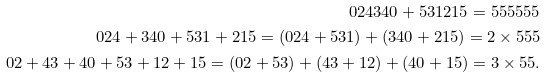<formula> <loc_0><loc_0><loc_500><loc_500>0 2 4 3 4 0 + 5 3 1 2 1 5 = 5 5 5 5 5 5 \\ 0 2 4 + 3 4 0 + 5 3 1 + 2 1 5 = ( 0 2 4 + 5 3 1 ) + ( 3 4 0 + 2 1 5 ) = 2 \times 5 5 5 \\ 0 2 + 4 3 + 4 0 + 5 3 + 1 2 + 1 5 = ( 0 2 + 5 3 ) + ( 4 3 + 1 2 ) + ( 4 0 + 1 5 ) = 3 \times 5 5 .</formula> 